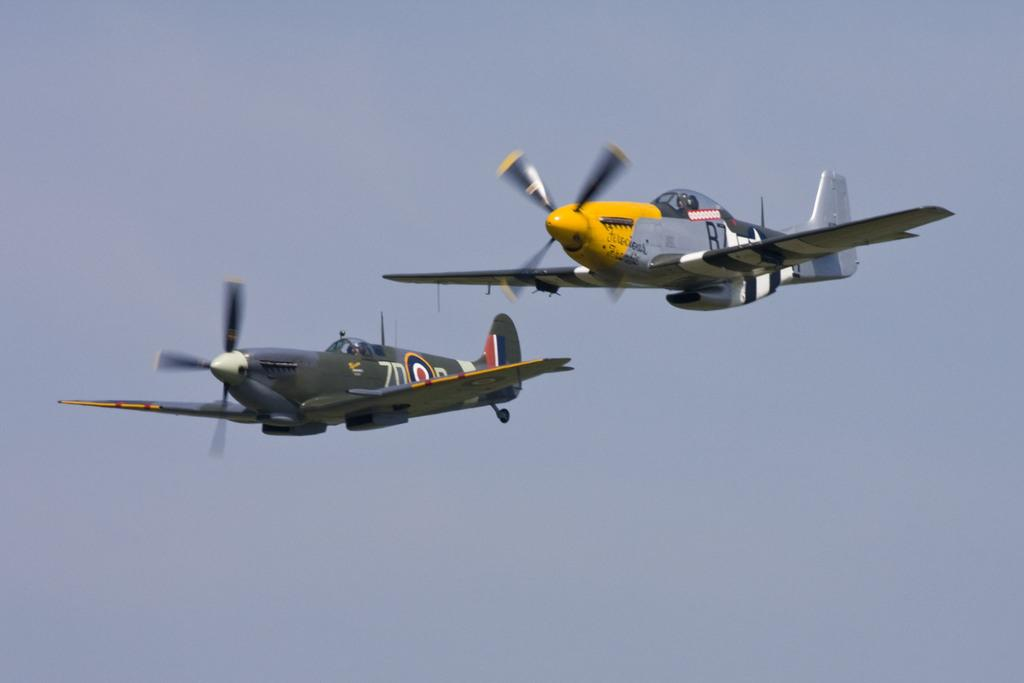<image>
Provide a brief description of the given image. Two prop airplanes fly side by side, one with B7 on the side. 